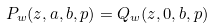Convert formula to latex. <formula><loc_0><loc_0><loc_500><loc_500>P _ { w } ( z , a , b , p ) = Q _ { w } ( z , 0 , b , p )</formula> 